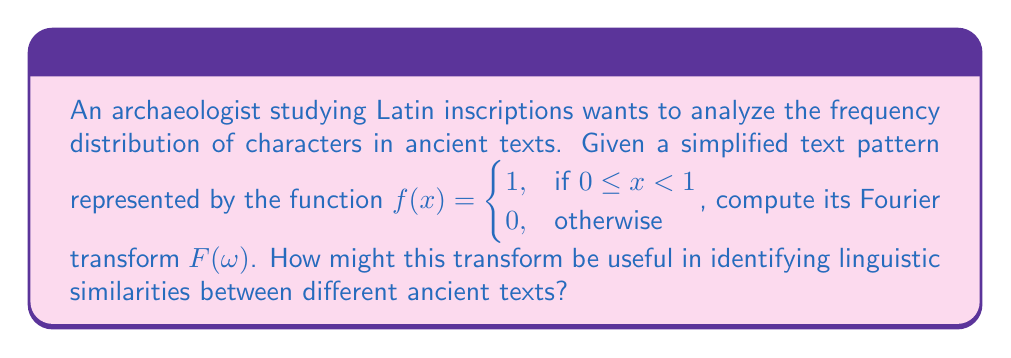Could you help me with this problem? To compute the Fourier transform of the given function, we use the definition:

$$F(\omega) = \int_{-\infty}^{\infty} f(x) e^{-i\omega x} dx$$

For our specific function:

$$F(\omega) = \int_{0}^{1} 1 \cdot e^{-i\omega x} dx$$

We can solve this integral:

$$\begin{align}
F(\omega) &= \left[-\frac{1}{i\omega} e^{-i\omega x}\right]_{0}^{1} \\
&= -\frac{1}{i\omega} (e^{-i\omega} - 1) \\
&= \frac{1}{i\omega} (1 - e^{-i\omega}) \\
&= \frac{1}{i\omega} (1 - \cos\omega + i\sin\omega) \\
&= \frac{\sin\omega}{\omega} - i\frac{1-\cos\omega}{\omega}
\end{align}$$

The magnitude of this transform is:

$$|F(\omega)| = \sqrt{\left(\frac{\sin\omega}{\omega}\right)^2 + \left(\frac{1-\cos\omega}{\omega}\right)^2}$$

This Fourier transform can be useful in identifying linguistic similarities between ancient texts in several ways:

1. Character frequency analysis: The magnitude of the Fourier transform at different frequencies can reveal patterns in character distributions, which may be characteristic of specific languages or writing styles.

2. Periodicity detection: Peaks in the Fourier transform can indicate repeating patterns in the text, which might correspond to common prefixes, suffixes, or grammatical structures in the language.

3. Text comparison: By comparing the Fourier transforms of different texts, archaeologists can identify similarities in their frequency distributions, potentially indicating shared linguistic origins or influences.

4. Noise reduction: The Fourier transform can help separate meaningful linguistic patterns from noise or degradation in ancient inscriptions, aiding in text reconstruction and analysis.

5. Language evolution studies: By analyzing the Fourier transforms of texts from different time periods, researchers can track changes in character usage and linguistic structures over time.
Answer: The Fourier transform of the given function is:

$$F(\omega) = \frac{\sin\omega}{\omega} - i\frac{1-\cos\omega}{\omega}$$

with magnitude:

$$|F(\omega)| = \sqrt{\left(\frac{\sin\omega}{\omega}\right)^2 + \left(\frac{1-\cos\omega}{\omega}\right)^2}$$

This transform can be used to analyze character frequency distributions, detect periodicities, compare texts, reduce noise, and study language evolution in ancient Latin inscriptions. 